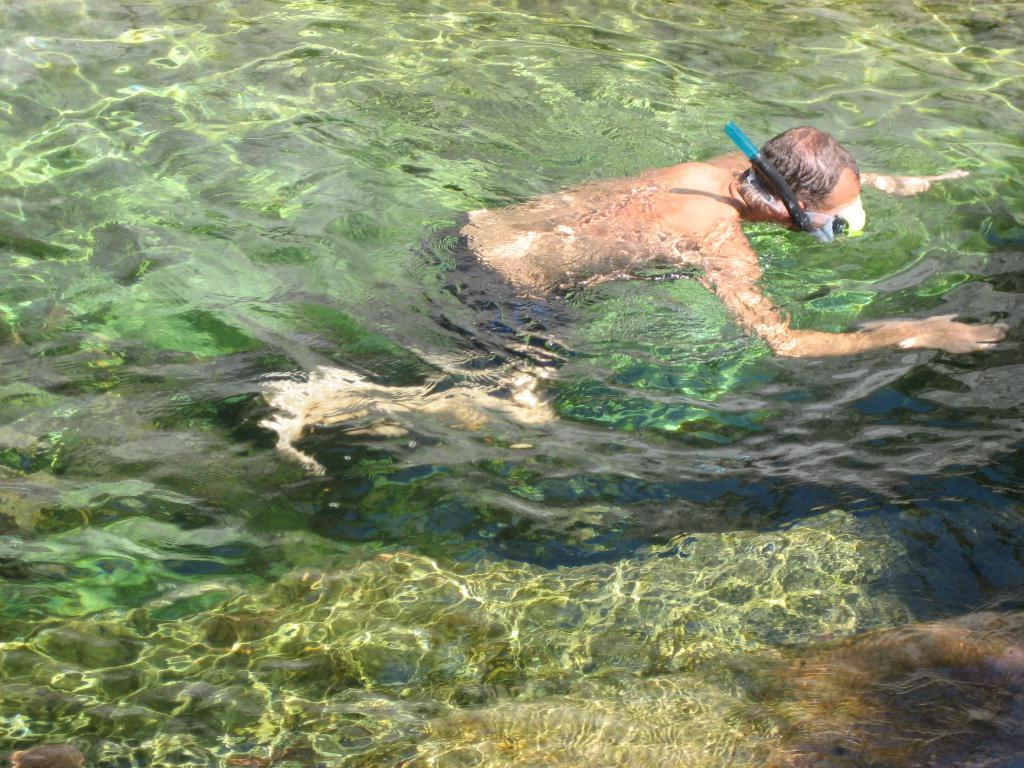Who is present in the image? There is a person in the image. What is the person doing in the image? The person is swimming in the water. What type of spoon is floating on the cloud in the image? There is no spoon or cloud present in the image; it features a person swimming in the water. 